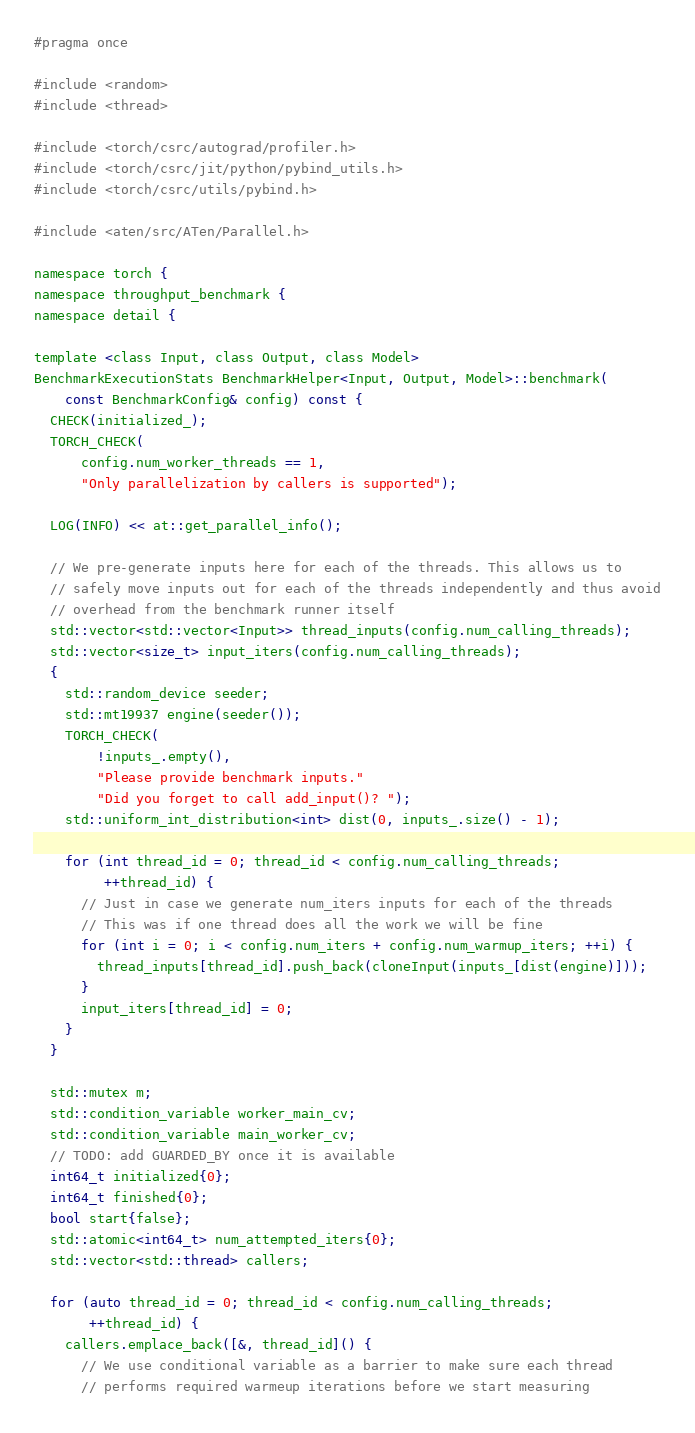<code> <loc_0><loc_0><loc_500><loc_500><_C_>#pragma once

#include <random>
#include <thread>

#include <torch/csrc/autograd/profiler.h>
#include <torch/csrc/jit/python/pybind_utils.h>
#include <torch/csrc/utils/pybind.h>

#include <aten/src/ATen/Parallel.h>

namespace torch {
namespace throughput_benchmark {
namespace detail {

template <class Input, class Output, class Model>
BenchmarkExecutionStats BenchmarkHelper<Input, Output, Model>::benchmark(
    const BenchmarkConfig& config) const {
  CHECK(initialized_);
  TORCH_CHECK(
      config.num_worker_threads == 1,
      "Only parallelization by callers is supported");

  LOG(INFO) << at::get_parallel_info();

  // We pre-generate inputs here for each of the threads. This allows us to
  // safely move inputs out for each of the threads independently and thus avoid
  // overhead from the benchmark runner itself
  std::vector<std::vector<Input>> thread_inputs(config.num_calling_threads);
  std::vector<size_t> input_iters(config.num_calling_threads);
  {
    std::random_device seeder;
    std::mt19937 engine(seeder());
    TORCH_CHECK(
        !inputs_.empty(),
        "Please provide benchmark inputs."
        "Did you forget to call add_input()? ");
    std::uniform_int_distribution<int> dist(0, inputs_.size() - 1);

    for (int thread_id = 0; thread_id < config.num_calling_threads;
         ++thread_id) {
      // Just in case we generate num_iters inputs for each of the threads
      // This was if one thread does all the work we will be fine
      for (int i = 0; i < config.num_iters + config.num_warmup_iters; ++i) {
        thread_inputs[thread_id].push_back(cloneInput(inputs_[dist(engine)]));
      }
      input_iters[thread_id] = 0;
    }
  }

  std::mutex m;
  std::condition_variable worker_main_cv;
  std::condition_variable main_worker_cv;
  // TODO: add GUARDED_BY once it is available
  int64_t initialized{0};
  int64_t finished{0};
  bool start{false};
  std::atomic<int64_t> num_attempted_iters{0};
  std::vector<std::thread> callers;

  for (auto thread_id = 0; thread_id < config.num_calling_threads;
       ++thread_id) {
    callers.emplace_back([&, thread_id]() {
      // We use conditional variable as a barrier to make sure each thread
      // performs required warmeup iterations before we start measuring</code> 